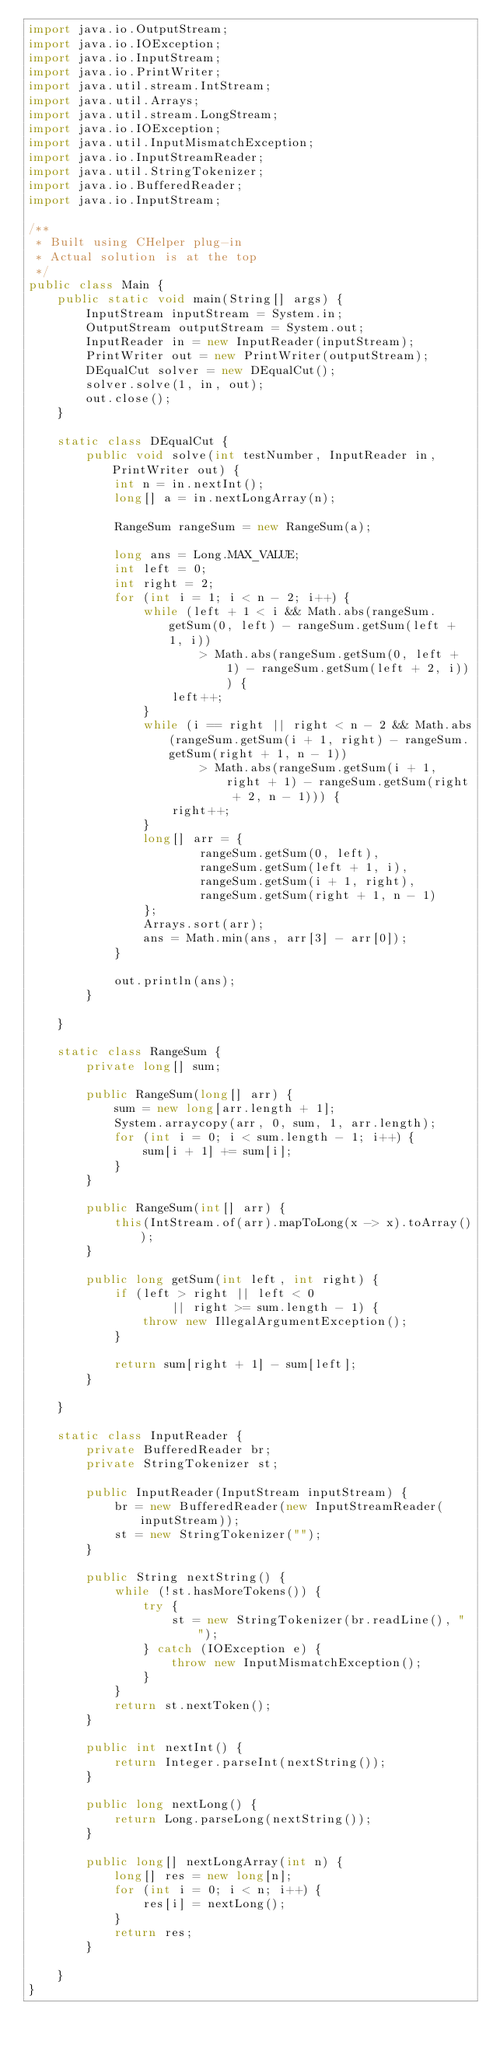<code> <loc_0><loc_0><loc_500><loc_500><_Java_>import java.io.OutputStream;
import java.io.IOException;
import java.io.InputStream;
import java.io.PrintWriter;
import java.util.stream.IntStream;
import java.util.Arrays;
import java.util.stream.LongStream;
import java.io.IOException;
import java.util.InputMismatchException;
import java.io.InputStreamReader;
import java.util.StringTokenizer;
import java.io.BufferedReader;
import java.io.InputStream;

/**
 * Built using CHelper plug-in
 * Actual solution is at the top
 */
public class Main {
    public static void main(String[] args) {
        InputStream inputStream = System.in;
        OutputStream outputStream = System.out;
        InputReader in = new InputReader(inputStream);
        PrintWriter out = new PrintWriter(outputStream);
        DEqualCut solver = new DEqualCut();
        solver.solve(1, in, out);
        out.close();
    }

    static class DEqualCut {
        public void solve(int testNumber, InputReader in, PrintWriter out) {
            int n = in.nextInt();
            long[] a = in.nextLongArray(n);

            RangeSum rangeSum = new RangeSum(a);

            long ans = Long.MAX_VALUE;
            int left = 0;
            int right = 2;
            for (int i = 1; i < n - 2; i++) {
                while (left + 1 < i && Math.abs(rangeSum.getSum(0, left) - rangeSum.getSum(left + 1, i))
                        > Math.abs(rangeSum.getSum(0, left + 1) - rangeSum.getSum(left + 2, i))) {
                    left++;
                }
                while (i == right || right < n - 2 && Math.abs(rangeSum.getSum(i + 1, right) - rangeSum.getSum(right + 1, n - 1))
                        > Math.abs(rangeSum.getSum(i + 1, right + 1) - rangeSum.getSum(right + 2, n - 1))) {
                    right++;
                }
                long[] arr = {
                        rangeSum.getSum(0, left),
                        rangeSum.getSum(left + 1, i),
                        rangeSum.getSum(i + 1, right),
                        rangeSum.getSum(right + 1, n - 1)
                };
                Arrays.sort(arr);
                ans = Math.min(ans, arr[3] - arr[0]);
            }

            out.println(ans);
        }

    }

    static class RangeSum {
        private long[] sum;

        public RangeSum(long[] arr) {
            sum = new long[arr.length + 1];
            System.arraycopy(arr, 0, sum, 1, arr.length);
            for (int i = 0; i < sum.length - 1; i++) {
                sum[i + 1] += sum[i];
            }
        }

        public RangeSum(int[] arr) {
            this(IntStream.of(arr).mapToLong(x -> x).toArray());
        }

        public long getSum(int left, int right) {
            if (left > right || left < 0
                    || right >= sum.length - 1) {
                throw new IllegalArgumentException();
            }

            return sum[right + 1] - sum[left];
        }

    }

    static class InputReader {
        private BufferedReader br;
        private StringTokenizer st;

        public InputReader(InputStream inputStream) {
            br = new BufferedReader(new InputStreamReader(inputStream));
            st = new StringTokenizer("");
        }

        public String nextString() {
            while (!st.hasMoreTokens()) {
                try {
                    st = new StringTokenizer(br.readLine(), " ");
                } catch (IOException e) {
                    throw new InputMismatchException();
                }
            }
            return st.nextToken();
        }

        public int nextInt() {
            return Integer.parseInt(nextString());
        }

        public long nextLong() {
            return Long.parseLong(nextString());
        }

        public long[] nextLongArray(int n) {
            long[] res = new long[n];
            for (int i = 0; i < n; i++) {
                res[i] = nextLong();
            }
            return res;
        }

    }
}

</code> 